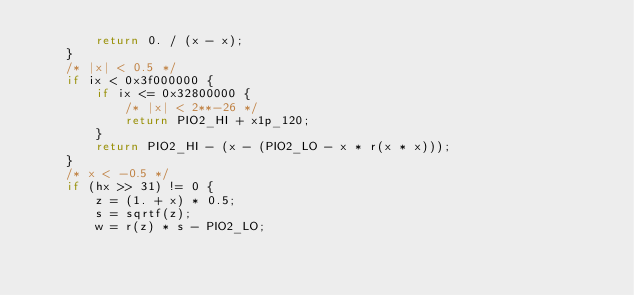Convert code to text. <code><loc_0><loc_0><loc_500><loc_500><_Rust_>        return 0. / (x - x);
    }
    /* |x| < 0.5 */
    if ix < 0x3f000000 {
        if ix <= 0x32800000 {
            /* |x| < 2**-26 */
            return PIO2_HI + x1p_120;
        }
        return PIO2_HI - (x - (PIO2_LO - x * r(x * x)));
    }
    /* x < -0.5 */
    if (hx >> 31) != 0 {
        z = (1. + x) * 0.5;
        s = sqrtf(z);
        w = r(z) * s - PIO2_LO;</code> 